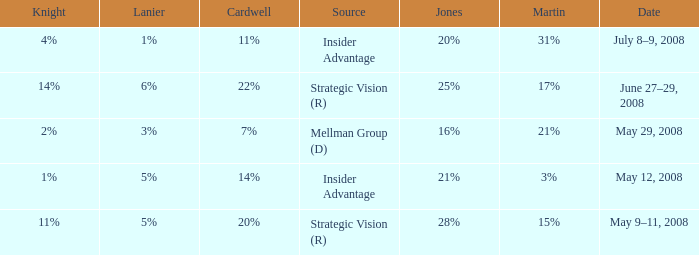What Lanier has a Cardwell of 20%? 5%. 